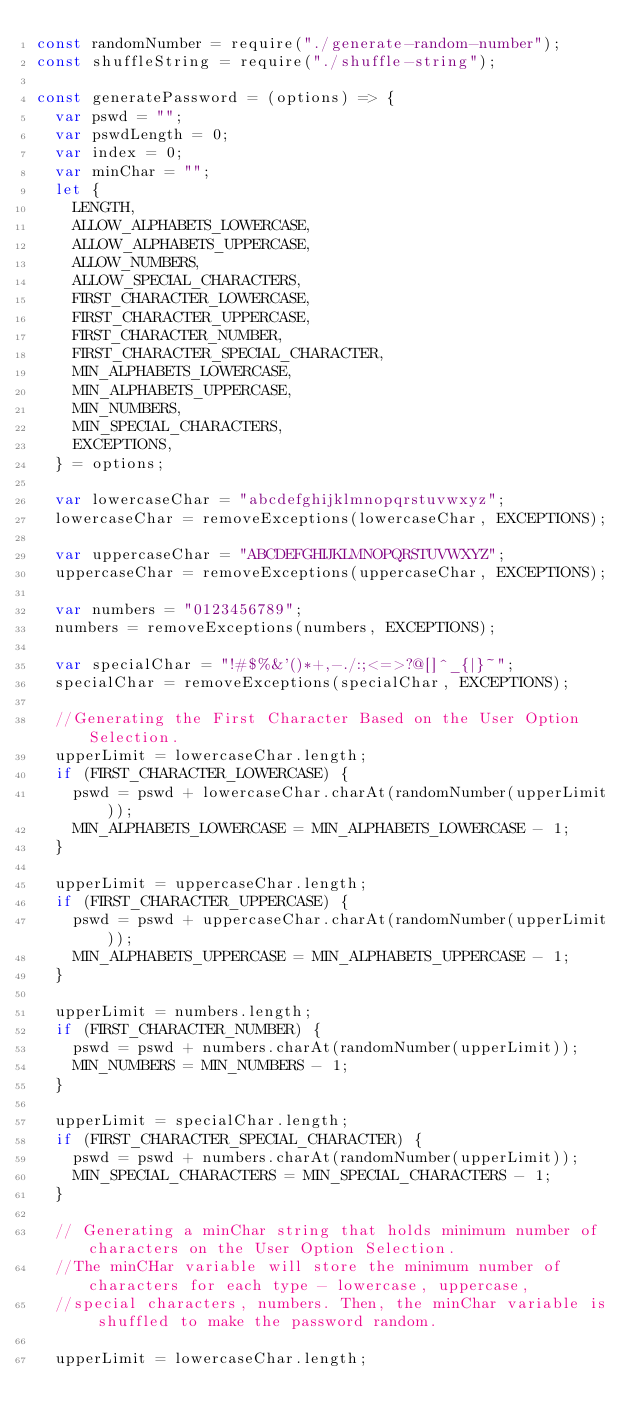Convert code to text. <code><loc_0><loc_0><loc_500><loc_500><_JavaScript_>const randomNumber = require("./generate-random-number");
const shuffleString = require("./shuffle-string");

const generatePassword = (options) => {
  var pswd = "";
  var pswdLength = 0;
  var index = 0;
  var minChar = "";
  let {
    LENGTH,
    ALLOW_ALPHABETS_LOWERCASE,
    ALLOW_ALPHABETS_UPPERCASE,
    ALLOW_NUMBERS,
    ALLOW_SPECIAL_CHARACTERS,
    FIRST_CHARACTER_LOWERCASE,
    FIRST_CHARACTER_UPPERCASE,
    FIRST_CHARACTER_NUMBER,
    FIRST_CHARACTER_SPECIAL_CHARACTER,
    MIN_ALPHABETS_LOWERCASE,
    MIN_ALPHABETS_UPPERCASE,
    MIN_NUMBERS,
    MIN_SPECIAL_CHARACTERS,
    EXCEPTIONS,
  } = options;

  var lowercaseChar = "abcdefghijklmnopqrstuvwxyz";
  lowercaseChar = removeExceptions(lowercaseChar, EXCEPTIONS);

  var uppercaseChar = "ABCDEFGHIJKLMNOPQRSTUVWXYZ";
  uppercaseChar = removeExceptions(uppercaseChar, EXCEPTIONS);

  var numbers = "0123456789";
  numbers = removeExceptions(numbers, EXCEPTIONS);

  var specialChar = "!#$%&'()*+,-./:;<=>?@[]^_{|}~";
  specialChar = removeExceptions(specialChar, EXCEPTIONS);

  //Generating the First Character Based on the User Option Selection.
  upperLimit = lowercaseChar.length;
  if (FIRST_CHARACTER_LOWERCASE) {
    pswd = pswd + lowercaseChar.charAt(randomNumber(upperLimit));
    MIN_ALPHABETS_LOWERCASE = MIN_ALPHABETS_LOWERCASE - 1;
  }

  upperLimit = uppercaseChar.length;
  if (FIRST_CHARACTER_UPPERCASE) {
    pswd = pswd + uppercaseChar.charAt(randomNumber(upperLimit));
    MIN_ALPHABETS_UPPERCASE = MIN_ALPHABETS_UPPERCASE - 1;
  }

  upperLimit = numbers.length;
  if (FIRST_CHARACTER_NUMBER) {
    pswd = pswd + numbers.charAt(randomNumber(upperLimit));
    MIN_NUMBERS = MIN_NUMBERS - 1;
  }

  upperLimit = specialChar.length;
  if (FIRST_CHARACTER_SPECIAL_CHARACTER) {
    pswd = pswd + numbers.charAt(randomNumber(upperLimit));
    MIN_SPECIAL_CHARACTERS = MIN_SPECIAL_CHARACTERS - 1;
  }

  // Generating a minChar string that holds minimum number of characters on the User Option Selection.
  //The minCHar variable will store the minimum number of characters for each type - lowercase, uppercase,
  //special characters, numbers. Then, the minChar variable is shuffled to make the password random.

  upperLimit = lowercaseChar.length;</code> 